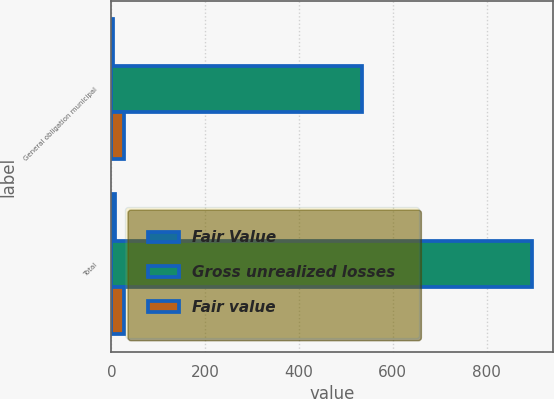Convert chart. <chart><loc_0><loc_0><loc_500><loc_500><stacked_bar_chart><ecel><fcel>General obligation municipal<fcel>Total<nl><fcel>Fair Value<fcel>3.8<fcel>7<nl><fcel>Gross unrealized losses<fcel>535.1<fcel>896.7<nl><fcel>Fair value<fcel>26.3<fcel>26.3<nl></chart> 